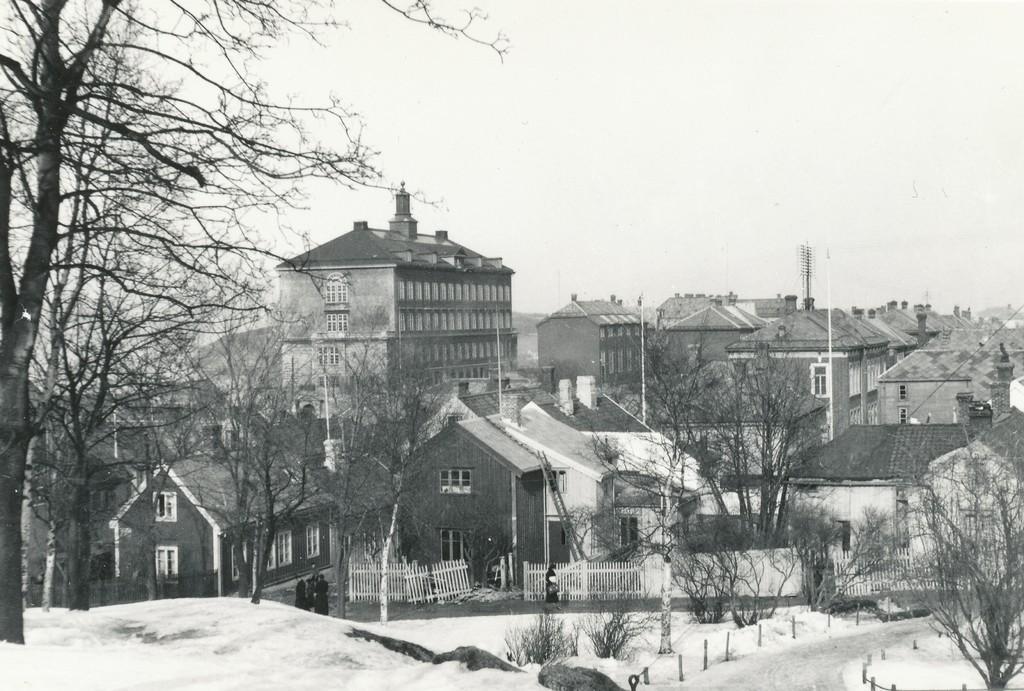In one or two sentences, can you explain what this image depicts? This is a black and white image. There are buildings, trees, fences and few people standing on the road. At the bottom of the image, I can see planets and the snow. In the background, there is the sky. 